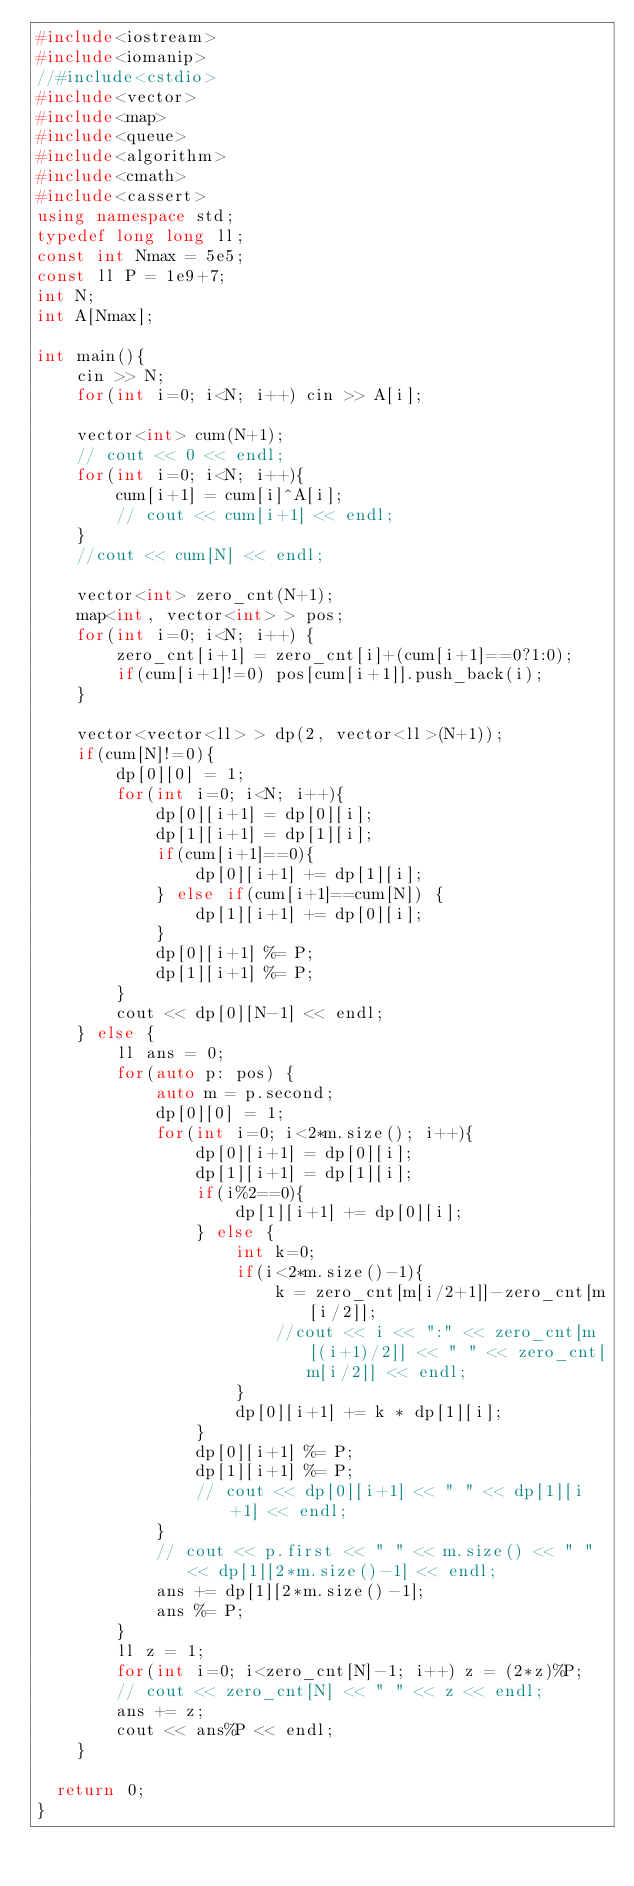Convert code to text. <code><loc_0><loc_0><loc_500><loc_500><_C++_>#include<iostream>
#include<iomanip>
//#include<cstdio>
#include<vector>
#include<map>
#include<queue>
#include<algorithm>
#include<cmath>
#include<cassert>
using namespace std;
typedef long long ll;
const int Nmax = 5e5;
const ll P = 1e9+7;
int N;
int A[Nmax];

int main(){
    cin >> N;
    for(int i=0; i<N; i++) cin >> A[i];

    vector<int> cum(N+1);
    // cout << 0 << endl;
    for(int i=0; i<N; i++){
        cum[i+1] = cum[i]^A[i];
        // cout << cum[i+1] << endl;
    }
    //cout << cum[N] << endl;

    vector<int> zero_cnt(N+1);
    map<int, vector<int> > pos;
    for(int i=0; i<N; i++) {
        zero_cnt[i+1] = zero_cnt[i]+(cum[i+1]==0?1:0);
        if(cum[i+1]!=0) pos[cum[i+1]].push_back(i);
    }

    vector<vector<ll> > dp(2, vector<ll>(N+1));
    if(cum[N]!=0){
        dp[0][0] = 1;
        for(int i=0; i<N; i++){
            dp[0][i+1] = dp[0][i];
            dp[1][i+1] = dp[1][i];
            if(cum[i+1]==0){
                dp[0][i+1] += dp[1][i];
            } else if(cum[i+1]==cum[N]) {
                dp[1][i+1] += dp[0][i];
            }
            dp[0][i+1] %= P;
            dp[1][i+1] %= P;
        }
        cout << dp[0][N-1] << endl;
    } else {
        ll ans = 0;
        for(auto p: pos) {
            auto m = p.second;
            dp[0][0] = 1;
            for(int i=0; i<2*m.size(); i++){
                dp[0][i+1] = dp[0][i];
                dp[1][i+1] = dp[1][i];
                if(i%2==0){
                    dp[1][i+1] += dp[0][i];
                } else {
                    int k=0;
                    if(i<2*m.size()-1){
                        k = zero_cnt[m[i/2+1]]-zero_cnt[m[i/2]];
                        //cout << i << ":" << zero_cnt[m[(i+1)/2]] << " " << zero_cnt[m[i/2]] << endl;
                    }
                    dp[0][i+1] += k * dp[1][i];
                }
                dp[0][i+1] %= P;
                dp[1][i+1] %= P;
                // cout << dp[0][i+1] << " " << dp[1][i+1] << endl;
            }
            // cout << p.first << " " << m.size() << " " << dp[1][2*m.size()-1] << endl;
            ans += dp[1][2*m.size()-1];
            ans %= P;
        }
        ll z = 1;
        for(int i=0; i<zero_cnt[N]-1; i++) z = (2*z)%P;
        // cout << zero_cnt[N] << " " << z << endl;
        ans += z;
        cout << ans%P << endl;
    }

	return 0;
}
</code> 